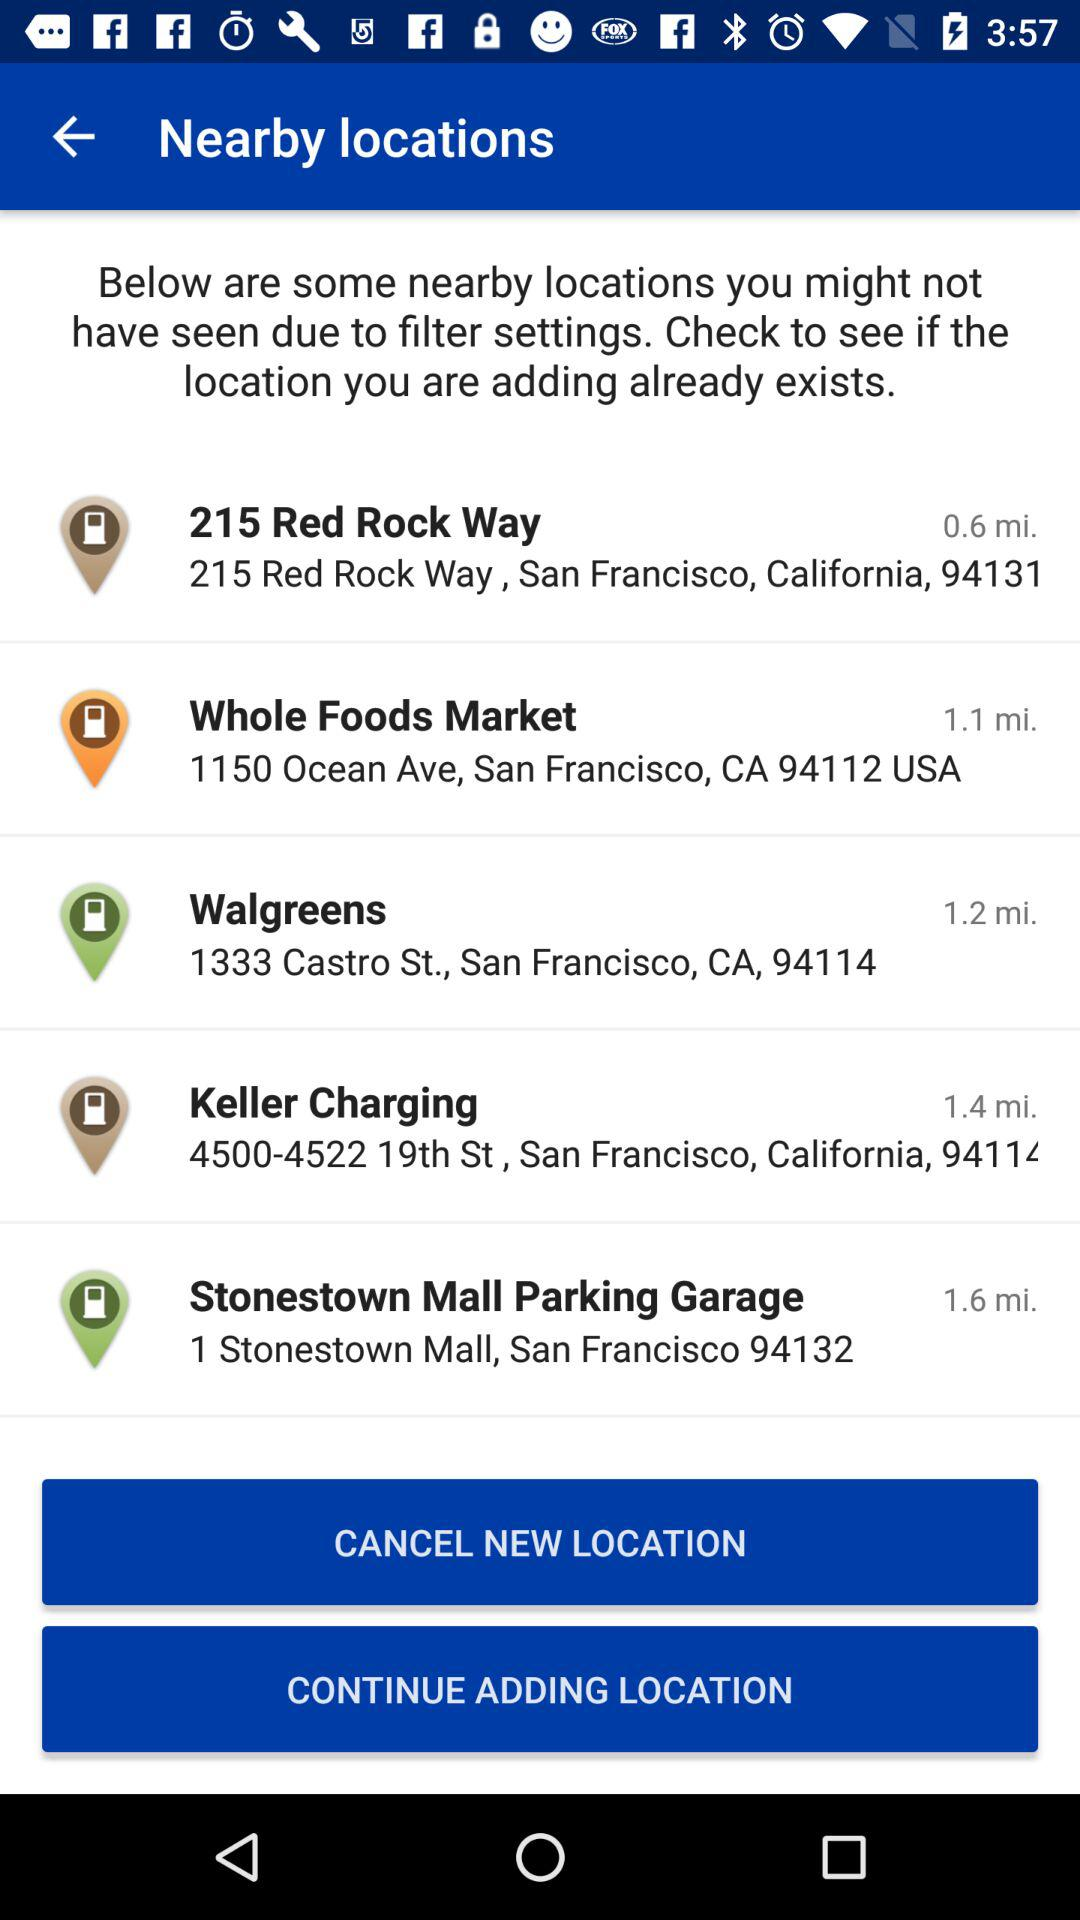How far is the Whole Foods Market? Whole Foods Market is 1.1 miles away. 